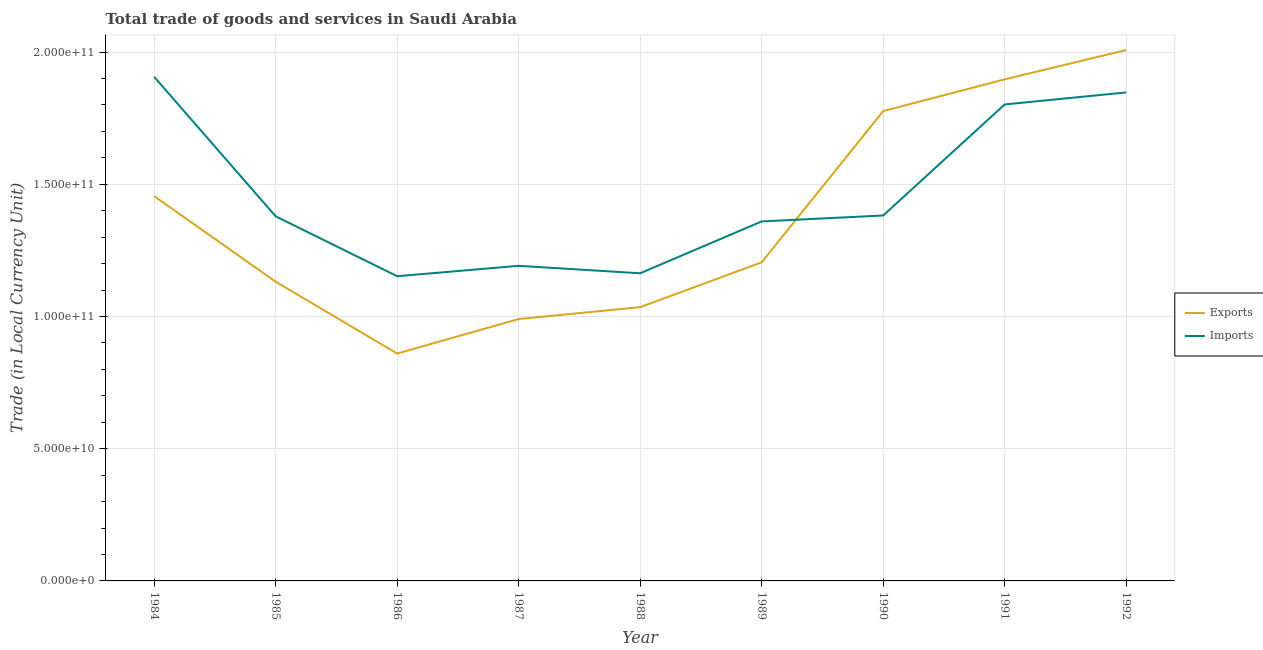Does the line corresponding to imports of goods and services intersect with the line corresponding to export of goods and services?
Offer a terse response. Yes. Is the number of lines equal to the number of legend labels?
Make the answer very short. Yes. What is the imports of goods and services in 1991?
Your response must be concise. 1.80e+11. Across all years, what is the maximum imports of goods and services?
Offer a very short reply. 1.91e+11. Across all years, what is the minimum export of goods and services?
Provide a succinct answer. 8.60e+1. In which year was the export of goods and services maximum?
Provide a succinct answer. 1992. In which year was the export of goods and services minimum?
Make the answer very short. 1986. What is the total imports of goods and services in the graph?
Offer a terse response. 1.32e+12. What is the difference between the export of goods and services in 1984 and that in 1985?
Offer a terse response. 3.24e+1. What is the difference between the export of goods and services in 1986 and the imports of goods and services in 1992?
Provide a short and direct response. -9.88e+1. What is the average imports of goods and services per year?
Your answer should be compact. 1.46e+11. In the year 1987, what is the difference between the imports of goods and services and export of goods and services?
Your answer should be compact. 2.01e+1. What is the ratio of the export of goods and services in 1986 to that in 1988?
Ensure brevity in your answer.  0.83. Is the difference between the imports of goods and services in 1986 and 1988 greater than the difference between the export of goods and services in 1986 and 1988?
Give a very brief answer. Yes. What is the difference between the highest and the second highest export of goods and services?
Provide a short and direct response. 1.11e+1. What is the difference between the highest and the lowest imports of goods and services?
Offer a very short reply. 7.54e+1. In how many years, is the export of goods and services greater than the average export of goods and services taken over all years?
Offer a terse response. 4. Is the sum of the imports of goods and services in 1985 and 1988 greater than the maximum export of goods and services across all years?
Offer a very short reply. Yes. Does the export of goods and services monotonically increase over the years?
Your response must be concise. No. Is the imports of goods and services strictly greater than the export of goods and services over the years?
Your answer should be compact. No. Are the values on the major ticks of Y-axis written in scientific E-notation?
Your answer should be very brief. Yes. Does the graph contain any zero values?
Provide a succinct answer. No. How are the legend labels stacked?
Your response must be concise. Vertical. What is the title of the graph?
Ensure brevity in your answer.  Total trade of goods and services in Saudi Arabia. What is the label or title of the X-axis?
Your answer should be very brief. Year. What is the label or title of the Y-axis?
Keep it short and to the point. Trade (in Local Currency Unit). What is the Trade (in Local Currency Unit) in Exports in 1984?
Your answer should be compact. 1.46e+11. What is the Trade (in Local Currency Unit) in Imports in 1984?
Make the answer very short. 1.91e+11. What is the Trade (in Local Currency Unit) of Exports in 1985?
Make the answer very short. 1.13e+11. What is the Trade (in Local Currency Unit) of Imports in 1985?
Offer a terse response. 1.38e+11. What is the Trade (in Local Currency Unit) of Exports in 1986?
Your answer should be compact. 8.60e+1. What is the Trade (in Local Currency Unit) in Imports in 1986?
Your answer should be compact. 1.15e+11. What is the Trade (in Local Currency Unit) in Exports in 1987?
Provide a succinct answer. 9.90e+1. What is the Trade (in Local Currency Unit) of Imports in 1987?
Offer a terse response. 1.19e+11. What is the Trade (in Local Currency Unit) in Exports in 1988?
Provide a short and direct response. 1.04e+11. What is the Trade (in Local Currency Unit) of Imports in 1988?
Your answer should be very brief. 1.16e+11. What is the Trade (in Local Currency Unit) in Exports in 1989?
Your response must be concise. 1.20e+11. What is the Trade (in Local Currency Unit) in Imports in 1989?
Make the answer very short. 1.36e+11. What is the Trade (in Local Currency Unit) of Exports in 1990?
Provide a short and direct response. 1.78e+11. What is the Trade (in Local Currency Unit) of Imports in 1990?
Offer a very short reply. 1.38e+11. What is the Trade (in Local Currency Unit) in Exports in 1991?
Provide a short and direct response. 1.90e+11. What is the Trade (in Local Currency Unit) in Imports in 1991?
Your answer should be compact. 1.80e+11. What is the Trade (in Local Currency Unit) of Exports in 1992?
Provide a short and direct response. 2.01e+11. What is the Trade (in Local Currency Unit) of Imports in 1992?
Your answer should be very brief. 1.85e+11. Across all years, what is the maximum Trade (in Local Currency Unit) in Exports?
Ensure brevity in your answer.  2.01e+11. Across all years, what is the maximum Trade (in Local Currency Unit) in Imports?
Make the answer very short. 1.91e+11. Across all years, what is the minimum Trade (in Local Currency Unit) in Exports?
Provide a succinct answer. 8.60e+1. Across all years, what is the minimum Trade (in Local Currency Unit) of Imports?
Offer a terse response. 1.15e+11. What is the total Trade (in Local Currency Unit) in Exports in the graph?
Provide a short and direct response. 1.24e+12. What is the total Trade (in Local Currency Unit) in Imports in the graph?
Your answer should be very brief. 1.32e+12. What is the difference between the Trade (in Local Currency Unit) of Exports in 1984 and that in 1985?
Your answer should be compact. 3.24e+1. What is the difference between the Trade (in Local Currency Unit) in Imports in 1984 and that in 1985?
Provide a short and direct response. 5.27e+1. What is the difference between the Trade (in Local Currency Unit) in Exports in 1984 and that in 1986?
Offer a terse response. 5.95e+1. What is the difference between the Trade (in Local Currency Unit) of Imports in 1984 and that in 1986?
Provide a short and direct response. 7.54e+1. What is the difference between the Trade (in Local Currency Unit) of Exports in 1984 and that in 1987?
Ensure brevity in your answer.  4.65e+1. What is the difference between the Trade (in Local Currency Unit) of Imports in 1984 and that in 1987?
Your answer should be compact. 7.15e+1. What is the difference between the Trade (in Local Currency Unit) of Exports in 1984 and that in 1988?
Ensure brevity in your answer.  4.20e+1. What is the difference between the Trade (in Local Currency Unit) in Imports in 1984 and that in 1988?
Your answer should be compact. 7.43e+1. What is the difference between the Trade (in Local Currency Unit) in Exports in 1984 and that in 1989?
Make the answer very short. 2.50e+1. What is the difference between the Trade (in Local Currency Unit) in Imports in 1984 and that in 1989?
Provide a short and direct response. 5.47e+1. What is the difference between the Trade (in Local Currency Unit) in Exports in 1984 and that in 1990?
Give a very brief answer. -3.22e+1. What is the difference between the Trade (in Local Currency Unit) in Imports in 1984 and that in 1990?
Your answer should be very brief. 5.24e+1. What is the difference between the Trade (in Local Currency Unit) in Exports in 1984 and that in 1991?
Make the answer very short. -4.42e+1. What is the difference between the Trade (in Local Currency Unit) in Imports in 1984 and that in 1991?
Ensure brevity in your answer.  1.04e+1. What is the difference between the Trade (in Local Currency Unit) of Exports in 1984 and that in 1992?
Ensure brevity in your answer.  -5.52e+1. What is the difference between the Trade (in Local Currency Unit) in Imports in 1984 and that in 1992?
Your answer should be compact. 5.89e+09. What is the difference between the Trade (in Local Currency Unit) of Exports in 1985 and that in 1986?
Keep it short and to the point. 2.72e+1. What is the difference between the Trade (in Local Currency Unit) of Imports in 1985 and that in 1986?
Your response must be concise. 2.27e+1. What is the difference between the Trade (in Local Currency Unit) in Exports in 1985 and that in 1987?
Ensure brevity in your answer.  1.41e+1. What is the difference between the Trade (in Local Currency Unit) in Imports in 1985 and that in 1987?
Offer a very short reply. 1.87e+1. What is the difference between the Trade (in Local Currency Unit) of Exports in 1985 and that in 1988?
Your response must be concise. 9.63e+09. What is the difference between the Trade (in Local Currency Unit) of Imports in 1985 and that in 1988?
Make the answer very short. 2.15e+1. What is the difference between the Trade (in Local Currency Unit) in Exports in 1985 and that in 1989?
Make the answer very short. -7.33e+09. What is the difference between the Trade (in Local Currency Unit) in Imports in 1985 and that in 1989?
Provide a succinct answer. 1.93e+09. What is the difference between the Trade (in Local Currency Unit) in Exports in 1985 and that in 1990?
Your answer should be very brief. -6.45e+1. What is the difference between the Trade (in Local Currency Unit) in Imports in 1985 and that in 1990?
Your answer should be compact. -3.15e+08. What is the difference between the Trade (in Local Currency Unit) in Exports in 1985 and that in 1991?
Offer a very short reply. -7.65e+1. What is the difference between the Trade (in Local Currency Unit) of Imports in 1985 and that in 1991?
Make the answer very short. -4.23e+1. What is the difference between the Trade (in Local Currency Unit) in Exports in 1985 and that in 1992?
Keep it short and to the point. -8.76e+1. What is the difference between the Trade (in Local Currency Unit) of Imports in 1985 and that in 1992?
Ensure brevity in your answer.  -4.69e+1. What is the difference between the Trade (in Local Currency Unit) in Exports in 1986 and that in 1987?
Keep it short and to the point. -1.31e+1. What is the difference between the Trade (in Local Currency Unit) of Imports in 1986 and that in 1987?
Keep it short and to the point. -3.93e+09. What is the difference between the Trade (in Local Currency Unit) in Exports in 1986 and that in 1988?
Offer a terse response. -1.75e+1. What is the difference between the Trade (in Local Currency Unit) of Imports in 1986 and that in 1988?
Ensure brevity in your answer.  -1.11e+09. What is the difference between the Trade (in Local Currency Unit) of Exports in 1986 and that in 1989?
Ensure brevity in your answer.  -3.45e+1. What is the difference between the Trade (in Local Currency Unit) in Imports in 1986 and that in 1989?
Keep it short and to the point. -2.07e+1. What is the difference between the Trade (in Local Currency Unit) of Exports in 1986 and that in 1990?
Provide a succinct answer. -9.17e+1. What is the difference between the Trade (in Local Currency Unit) in Imports in 1986 and that in 1990?
Make the answer very short. -2.30e+1. What is the difference between the Trade (in Local Currency Unit) of Exports in 1986 and that in 1991?
Your answer should be compact. -1.04e+11. What is the difference between the Trade (in Local Currency Unit) of Imports in 1986 and that in 1991?
Offer a very short reply. -6.50e+1. What is the difference between the Trade (in Local Currency Unit) in Exports in 1986 and that in 1992?
Your response must be concise. -1.15e+11. What is the difference between the Trade (in Local Currency Unit) of Imports in 1986 and that in 1992?
Provide a short and direct response. -6.95e+1. What is the difference between the Trade (in Local Currency Unit) of Exports in 1987 and that in 1988?
Offer a terse response. -4.49e+09. What is the difference between the Trade (in Local Currency Unit) in Imports in 1987 and that in 1988?
Your answer should be very brief. 2.82e+09. What is the difference between the Trade (in Local Currency Unit) in Exports in 1987 and that in 1989?
Provide a succinct answer. -2.14e+1. What is the difference between the Trade (in Local Currency Unit) of Imports in 1987 and that in 1989?
Provide a short and direct response. -1.68e+1. What is the difference between the Trade (in Local Currency Unit) in Exports in 1987 and that in 1990?
Offer a terse response. -7.86e+1. What is the difference between the Trade (in Local Currency Unit) of Imports in 1987 and that in 1990?
Offer a very short reply. -1.90e+1. What is the difference between the Trade (in Local Currency Unit) in Exports in 1987 and that in 1991?
Your response must be concise. -9.06e+1. What is the difference between the Trade (in Local Currency Unit) in Imports in 1987 and that in 1991?
Your answer should be compact. -6.10e+1. What is the difference between the Trade (in Local Currency Unit) in Exports in 1987 and that in 1992?
Ensure brevity in your answer.  -1.02e+11. What is the difference between the Trade (in Local Currency Unit) in Imports in 1987 and that in 1992?
Your answer should be compact. -6.56e+1. What is the difference between the Trade (in Local Currency Unit) in Exports in 1988 and that in 1989?
Make the answer very short. -1.70e+1. What is the difference between the Trade (in Local Currency Unit) in Imports in 1988 and that in 1989?
Provide a succinct answer. -1.96e+1. What is the difference between the Trade (in Local Currency Unit) in Exports in 1988 and that in 1990?
Ensure brevity in your answer.  -7.42e+1. What is the difference between the Trade (in Local Currency Unit) of Imports in 1988 and that in 1990?
Offer a terse response. -2.19e+1. What is the difference between the Trade (in Local Currency Unit) in Exports in 1988 and that in 1991?
Offer a very short reply. -8.62e+1. What is the difference between the Trade (in Local Currency Unit) in Imports in 1988 and that in 1991?
Ensure brevity in your answer.  -6.38e+1. What is the difference between the Trade (in Local Currency Unit) in Exports in 1988 and that in 1992?
Provide a short and direct response. -9.72e+1. What is the difference between the Trade (in Local Currency Unit) of Imports in 1988 and that in 1992?
Offer a terse response. -6.84e+1. What is the difference between the Trade (in Local Currency Unit) in Exports in 1989 and that in 1990?
Ensure brevity in your answer.  -5.72e+1. What is the difference between the Trade (in Local Currency Unit) of Imports in 1989 and that in 1990?
Keep it short and to the point. -2.25e+09. What is the difference between the Trade (in Local Currency Unit) in Exports in 1989 and that in 1991?
Ensure brevity in your answer.  -6.92e+1. What is the difference between the Trade (in Local Currency Unit) of Imports in 1989 and that in 1991?
Your answer should be very brief. -4.42e+1. What is the difference between the Trade (in Local Currency Unit) of Exports in 1989 and that in 1992?
Your answer should be very brief. -8.03e+1. What is the difference between the Trade (in Local Currency Unit) in Imports in 1989 and that in 1992?
Your response must be concise. -4.88e+1. What is the difference between the Trade (in Local Currency Unit) of Exports in 1990 and that in 1991?
Ensure brevity in your answer.  -1.20e+1. What is the difference between the Trade (in Local Currency Unit) in Imports in 1990 and that in 1991?
Your response must be concise. -4.20e+1. What is the difference between the Trade (in Local Currency Unit) of Exports in 1990 and that in 1992?
Ensure brevity in your answer.  -2.31e+1. What is the difference between the Trade (in Local Currency Unit) of Imports in 1990 and that in 1992?
Give a very brief answer. -4.65e+1. What is the difference between the Trade (in Local Currency Unit) in Exports in 1991 and that in 1992?
Your answer should be compact. -1.11e+1. What is the difference between the Trade (in Local Currency Unit) of Imports in 1991 and that in 1992?
Your response must be concise. -4.55e+09. What is the difference between the Trade (in Local Currency Unit) of Exports in 1984 and the Trade (in Local Currency Unit) of Imports in 1985?
Provide a succinct answer. 7.64e+09. What is the difference between the Trade (in Local Currency Unit) in Exports in 1984 and the Trade (in Local Currency Unit) in Imports in 1986?
Your answer should be very brief. 3.03e+1. What is the difference between the Trade (in Local Currency Unit) of Exports in 1984 and the Trade (in Local Currency Unit) of Imports in 1987?
Your answer should be compact. 2.64e+1. What is the difference between the Trade (in Local Currency Unit) of Exports in 1984 and the Trade (in Local Currency Unit) of Imports in 1988?
Provide a short and direct response. 2.92e+1. What is the difference between the Trade (in Local Currency Unit) in Exports in 1984 and the Trade (in Local Currency Unit) in Imports in 1989?
Your answer should be compact. 9.57e+09. What is the difference between the Trade (in Local Currency Unit) of Exports in 1984 and the Trade (in Local Currency Unit) of Imports in 1990?
Provide a short and direct response. 7.32e+09. What is the difference between the Trade (in Local Currency Unit) of Exports in 1984 and the Trade (in Local Currency Unit) of Imports in 1991?
Your response must be concise. -3.47e+1. What is the difference between the Trade (in Local Currency Unit) of Exports in 1984 and the Trade (in Local Currency Unit) of Imports in 1992?
Keep it short and to the point. -3.92e+1. What is the difference between the Trade (in Local Currency Unit) of Exports in 1985 and the Trade (in Local Currency Unit) of Imports in 1986?
Keep it short and to the point. -2.08e+09. What is the difference between the Trade (in Local Currency Unit) of Exports in 1985 and the Trade (in Local Currency Unit) of Imports in 1987?
Offer a very short reply. -6.01e+09. What is the difference between the Trade (in Local Currency Unit) of Exports in 1985 and the Trade (in Local Currency Unit) of Imports in 1988?
Give a very brief answer. -3.19e+09. What is the difference between the Trade (in Local Currency Unit) of Exports in 1985 and the Trade (in Local Currency Unit) of Imports in 1989?
Provide a short and direct response. -2.28e+1. What is the difference between the Trade (in Local Currency Unit) of Exports in 1985 and the Trade (in Local Currency Unit) of Imports in 1990?
Give a very brief answer. -2.50e+1. What is the difference between the Trade (in Local Currency Unit) in Exports in 1985 and the Trade (in Local Currency Unit) in Imports in 1991?
Your answer should be compact. -6.70e+1. What is the difference between the Trade (in Local Currency Unit) in Exports in 1985 and the Trade (in Local Currency Unit) in Imports in 1992?
Offer a very short reply. -7.16e+1. What is the difference between the Trade (in Local Currency Unit) in Exports in 1986 and the Trade (in Local Currency Unit) in Imports in 1987?
Your answer should be very brief. -3.32e+1. What is the difference between the Trade (in Local Currency Unit) in Exports in 1986 and the Trade (in Local Currency Unit) in Imports in 1988?
Your response must be concise. -3.04e+1. What is the difference between the Trade (in Local Currency Unit) in Exports in 1986 and the Trade (in Local Currency Unit) in Imports in 1989?
Your response must be concise. -5.00e+1. What is the difference between the Trade (in Local Currency Unit) in Exports in 1986 and the Trade (in Local Currency Unit) in Imports in 1990?
Keep it short and to the point. -5.22e+1. What is the difference between the Trade (in Local Currency Unit) in Exports in 1986 and the Trade (in Local Currency Unit) in Imports in 1991?
Provide a succinct answer. -9.42e+1. What is the difference between the Trade (in Local Currency Unit) in Exports in 1986 and the Trade (in Local Currency Unit) in Imports in 1992?
Make the answer very short. -9.88e+1. What is the difference between the Trade (in Local Currency Unit) of Exports in 1987 and the Trade (in Local Currency Unit) of Imports in 1988?
Ensure brevity in your answer.  -1.73e+1. What is the difference between the Trade (in Local Currency Unit) of Exports in 1987 and the Trade (in Local Currency Unit) of Imports in 1989?
Provide a succinct answer. -3.69e+1. What is the difference between the Trade (in Local Currency Unit) of Exports in 1987 and the Trade (in Local Currency Unit) of Imports in 1990?
Give a very brief answer. -3.92e+1. What is the difference between the Trade (in Local Currency Unit) of Exports in 1987 and the Trade (in Local Currency Unit) of Imports in 1991?
Offer a terse response. -8.12e+1. What is the difference between the Trade (in Local Currency Unit) in Exports in 1987 and the Trade (in Local Currency Unit) in Imports in 1992?
Provide a succinct answer. -8.57e+1. What is the difference between the Trade (in Local Currency Unit) in Exports in 1988 and the Trade (in Local Currency Unit) in Imports in 1989?
Make the answer very short. -3.24e+1. What is the difference between the Trade (in Local Currency Unit) of Exports in 1988 and the Trade (in Local Currency Unit) of Imports in 1990?
Ensure brevity in your answer.  -3.47e+1. What is the difference between the Trade (in Local Currency Unit) of Exports in 1988 and the Trade (in Local Currency Unit) of Imports in 1991?
Give a very brief answer. -7.67e+1. What is the difference between the Trade (in Local Currency Unit) of Exports in 1988 and the Trade (in Local Currency Unit) of Imports in 1992?
Your response must be concise. -8.12e+1. What is the difference between the Trade (in Local Currency Unit) of Exports in 1989 and the Trade (in Local Currency Unit) of Imports in 1990?
Make the answer very short. -1.77e+1. What is the difference between the Trade (in Local Currency Unit) in Exports in 1989 and the Trade (in Local Currency Unit) in Imports in 1991?
Offer a very short reply. -5.97e+1. What is the difference between the Trade (in Local Currency Unit) of Exports in 1989 and the Trade (in Local Currency Unit) of Imports in 1992?
Provide a succinct answer. -6.43e+1. What is the difference between the Trade (in Local Currency Unit) in Exports in 1990 and the Trade (in Local Currency Unit) in Imports in 1991?
Offer a very short reply. -2.51e+09. What is the difference between the Trade (in Local Currency Unit) in Exports in 1990 and the Trade (in Local Currency Unit) in Imports in 1992?
Your answer should be very brief. -7.06e+09. What is the difference between the Trade (in Local Currency Unit) in Exports in 1991 and the Trade (in Local Currency Unit) in Imports in 1992?
Your answer should be compact. 4.95e+09. What is the average Trade (in Local Currency Unit) in Exports per year?
Give a very brief answer. 1.37e+11. What is the average Trade (in Local Currency Unit) of Imports per year?
Your answer should be very brief. 1.46e+11. In the year 1984, what is the difference between the Trade (in Local Currency Unit) of Exports and Trade (in Local Currency Unit) of Imports?
Your answer should be compact. -4.51e+1. In the year 1985, what is the difference between the Trade (in Local Currency Unit) in Exports and Trade (in Local Currency Unit) in Imports?
Your response must be concise. -2.47e+1. In the year 1986, what is the difference between the Trade (in Local Currency Unit) in Exports and Trade (in Local Currency Unit) in Imports?
Give a very brief answer. -2.92e+1. In the year 1987, what is the difference between the Trade (in Local Currency Unit) of Exports and Trade (in Local Currency Unit) of Imports?
Offer a very short reply. -2.01e+1. In the year 1988, what is the difference between the Trade (in Local Currency Unit) in Exports and Trade (in Local Currency Unit) in Imports?
Your answer should be compact. -1.28e+1. In the year 1989, what is the difference between the Trade (in Local Currency Unit) of Exports and Trade (in Local Currency Unit) of Imports?
Offer a very short reply. -1.55e+1. In the year 1990, what is the difference between the Trade (in Local Currency Unit) in Exports and Trade (in Local Currency Unit) in Imports?
Provide a short and direct response. 3.95e+1. In the year 1991, what is the difference between the Trade (in Local Currency Unit) in Exports and Trade (in Local Currency Unit) in Imports?
Your answer should be compact. 9.50e+09. In the year 1992, what is the difference between the Trade (in Local Currency Unit) of Exports and Trade (in Local Currency Unit) of Imports?
Keep it short and to the point. 1.60e+1. What is the ratio of the Trade (in Local Currency Unit) in Exports in 1984 to that in 1985?
Provide a short and direct response. 1.29. What is the ratio of the Trade (in Local Currency Unit) of Imports in 1984 to that in 1985?
Give a very brief answer. 1.38. What is the ratio of the Trade (in Local Currency Unit) in Exports in 1984 to that in 1986?
Give a very brief answer. 1.69. What is the ratio of the Trade (in Local Currency Unit) of Imports in 1984 to that in 1986?
Make the answer very short. 1.65. What is the ratio of the Trade (in Local Currency Unit) of Exports in 1984 to that in 1987?
Offer a terse response. 1.47. What is the ratio of the Trade (in Local Currency Unit) of Imports in 1984 to that in 1987?
Make the answer very short. 1.6. What is the ratio of the Trade (in Local Currency Unit) of Exports in 1984 to that in 1988?
Your answer should be very brief. 1.41. What is the ratio of the Trade (in Local Currency Unit) of Imports in 1984 to that in 1988?
Make the answer very short. 1.64. What is the ratio of the Trade (in Local Currency Unit) in Exports in 1984 to that in 1989?
Ensure brevity in your answer.  1.21. What is the ratio of the Trade (in Local Currency Unit) in Imports in 1984 to that in 1989?
Offer a terse response. 1.4. What is the ratio of the Trade (in Local Currency Unit) in Exports in 1984 to that in 1990?
Provide a short and direct response. 0.82. What is the ratio of the Trade (in Local Currency Unit) of Imports in 1984 to that in 1990?
Provide a short and direct response. 1.38. What is the ratio of the Trade (in Local Currency Unit) in Exports in 1984 to that in 1991?
Provide a succinct answer. 0.77. What is the ratio of the Trade (in Local Currency Unit) in Imports in 1984 to that in 1991?
Your response must be concise. 1.06. What is the ratio of the Trade (in Local Currency Unit) of Exports in 1984 to that in 1992?
Offer a very short reply. 0.72. What is the ratio of the Trade (in Local Currency Unit) of Imports in 1984 to that in 1992?
Make the answer very short. 1.03. What is the ratio of the Trade (in Local Currency Unit) in Exports in 1985 to that in 1986?
Your response must be concise. 1.32. What is the ratio of the Trade (in Local Currency Unit) of Imports in 1985 to that in 1986?
Your answer should be very brief. 1.2. What is the ratio of the Trade (in Local Currency Unit) in Exports in 1985 to that in 1987?
Your answer should be very brief. 1.14. What is the ratio of the Trade (in Local Currency Unit) in Imports in 1985 to that in 1987?
Offer a very short reply. 1.16. What is the ratio of the Trade (in Local Currency Unit) in Exports in 1985 to that in 1988?
Make the answer very short. 1.09. What is the ratio of the Trade (in Local Currency Unit) in Imports in 1985 to that in 1988?
Give a very brief answer. 1.19. What is the ratio of the Trade (in Local Currency Unit) of Exports in 1985 to that in 1989?
Offer a very short reply. 0.94. What is the ratio of the Trade (in Local Currency Unit) of Imports in 1985 to that in 1989?
Your answer should be compact. 1.01. What is the ratio of the Trade (in Local Currency Unit) in Exports in 1985 to that in 1990?
Your response must be concise. 0.64. What is the ratio of the Trade (in Local Currency Unit) in Exports in 1985 to that in 1991?
Give a very brief answer. 0.6. What is the ratio of the Trade (in Local Currency Unit) in Imports in 1985 to that in 1991?
Your answer should be compact. 0.77. What is the ratio of the Trade (in Local Currency Unit) in Exports in 1985 to that in 1992?
Provide a succinct answer. 0.56. What is the ratio of the Trade (in Local Currency Unit) in Imports in 1985 to that in 1992?
Your answer should be compact. 0.75. What is the ratio of the Trade (in Local Currency Unit) in Exports in 1986 to that in 1987?
Your response must be concise. 0.87. What is the ratio of the Trade (in Local Currency Unit) in Exports in 1986 to that in 1988?
Offer a very short reply. 0.83. What is the ratio of the Trade (in Local Currency Unit) of Imports in 1986 to that in 1988?
Provide a succinct answer. 0.99. What is the ratio of the Trade (in Local Currency Unit) in Exports in 1986 to that in 1989?
Keep it short and to the point. 0.71. What is the ratio of the Trade (in Local Currency Unit) in Imports in 1986 to that in 1989?
Your answer should be compact. 0.85. What is the ratio of the Trade (in Local Currency Unit) of Exports in 1986 to that in 1990?
Offer a terse response. 0.48. What is the ratio of the Trade (in Local Currency Unit) of Imports in 1986 to that in 1990?
Make the answer very short. 0.83. What is the ratio of the Trade (in Local Currency Unit) of Exports in 1986 to that in 1991?
Provide a short and direct response. 0.45. What is the ratio of the Trade (in Local Currency Unit) in Imports in 1986 to that in 1991?
Your answer should be compact. 0.64. What is the ratio of the Trade (in Local Currency Unit) of Exports in 1986 to that in 1992?
Keep it short and to the point. 0.43. What is the ratio of the Trade (in Local Currency Unit) of Imports in 1986 to that in 1992?
Make the answer very short. 0.62. What is the ratio of the Trade (in Local Currency Unit) in Exports in 1987 to that in 1988?
Your response must be concise. 0.96. What is the ratio of the Trade (in Local Currency Unit) of Imports in 1987 to that in 1988?
Give a very brief answer. 1.02. What is the ratio of the Trade (in Local Currency Unit) of Exports in 1987 to that in 1989?
Make the answer very short. 0.82. What is the ratio of the Trade (in Local Currency Unit) in Imports in 1987 to that in 1989?
Your answer should be compact. 0.88. What is the ratio of the Trade (in Local Currency Unit) in Exports in 1987 to that in 1990?
Your answer should be compact. 0.56. What is the ratio of the Trade (in Local Currency Unit) in Imports in 1987 to that in 1990?
Make the answer very short. 0.86. What is the ratio of the Trade (in Local Currency Unit) in Exports in 1987 to that in 1991?
Your answer should be very brief. 0.52. What is the ratio of the Trade (in Local Currency Unit) of Imports in 1987 to that in 1991?
Offer a terse response. 0.66. What is the ratio of the Trade (in Local Currency Unit) in Exports in 1987 to that in 1992?
Ensure brevity in your answer.  0.49. What is the ratio of the Trade (in Local Currency Unit) of Imports in 1987 to that in 1992?
Your response must be concise. 0.65. What is the ratio of the Trade (in Local Currency Unit) in Exports in 1988 to that in 1989?
Make the answer very short. 0.86. What is the ratio of the Trade (in Local Currency Unit) of Imports in 1988 to that in 1989?
Offer a terse response. 0.86. What is the ratio of the Trade (in Local Currency Unit) of Exports in 1988 to that in 1990?
Your response must be concise. 0.58. What is the ratio of the Trade (in Local Currency Unit) of Imports in 1988 to that in 1990?
Offer a terse response. 0.84. What is the ratio of the Trade (in Local Currency Unit) in Exports in 1988 to that in 1991?
Your answer should be compact. 0.55. What is the ratio of the Trade (in Local Currency Unit) of Imports in 1988 to that in 1991?
Provide a short and direct response. 0.65. What is the ratio of the Trade (in Local Currency Unit) of Exports in 1988 to that in 1992?
Offer a very short reply. 0.52. What is the ratio of the Trade (in Local Currency Unit) in Imports in 1988 to that in 1992?
Offer a very short reply. 0.63. What is the ratio of the Trade (in Local Currency Unit) of Exports in 1989 to that in 1990?
Offer a terse response. 0.68. What is the ratio of the Trade (in Local Currency Unit) of Imports in 1989 to that in 1990?
Provide a short and direct response. 0.98. What is the ratio of the Trade (in Local Currency Unit) of Exports in 1989 to that in 1991?
Give a very brief answer. 0.64. What is the ratio of the Trade (in Local Currency Unit) in Imports in 1989 to that in 1991?
Your answer should be compact. 0.75. What is the ratio of the Trade (in Local Currency Unit) of Exports in 1989 to that in 1992?
Provide a succinct answer. 0.6. What is the ratio of the Trade (in Local Currency Unit) of Imports in 1989 to that in 1992?
Keep it short and to the point. 0.74. What is the ratio of the Trade (in Local Currency Unit) in Exports in 1990 to that in 1991?
Provide a short and direct response. 0.94. What is the ratio of the Trade (in Local Currency Unit) of Imports in 1990 to that in 1991?
Ensure brevity in your answer.  0.77. What is the ratio of the Trade (in Local Currency Unit) of Exports in 1990 to that in 1992?
Your answer should be compact. 0.89. What is the ratio of the Trade (in Local Currency Unit) of Imports in 1990 to that in 1992?
Give a very brief answer. 0.75. What is the ratio of the Trade (in Local Currency Unit) in Exports in 1991 to that in 1992?
Provide a short and direct response. 0.94. What is the ratio of the Trade (in Local Currency Unit) of Imports in 1991 to that in 1992?
Ensure brevity in your answer.  0.98. What is the difference between the highest and the second highest Trade (in Local Currency Unit) of Exports?
Give a very brief answer. 1.11e+1. What is the difference between the highest and the second highest Trade (in Local Currency Unit) in Imports?
Keep it short and to the point. 5.89e+09. What is the difference between the highest and the lowest Trade (in Local Currency Unit) of Exports?
Offer a terse response. 1.15e+11. What is the difference between the highest and the lowest Trade (in Local Currency Unit) of Imports?
Give a very brief answer. 7.54e+1. 